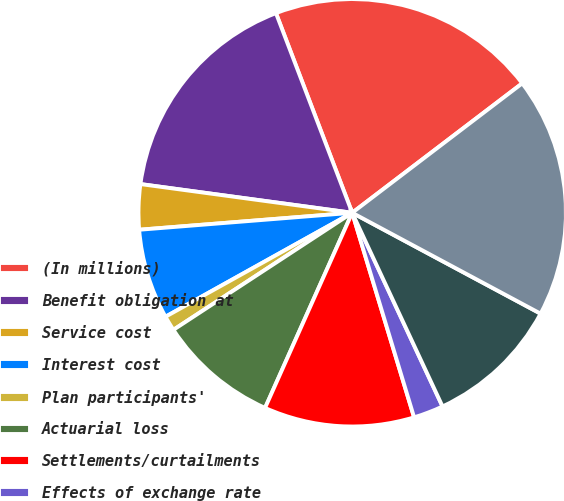Convert chart. <chart><loc_0><loc_0><loc_500><loc_500><pie_chart><fcel>(In millions)<fcel>Benefit obligation at<fcel>Service cost<fcel>Interest cost<fcel>Plan participants'<fcel>Actuarial loss<fcel>Settlements/curtailments<fcel>Effects of exchange rate<fcel>Benefits paid<fcel>Benefit obligation at end of<nl><fcel>20.45%<fcel>17.05%<fcel>3.41%<fcel>6.82%<fcel>1.14%<fcel>9.09%<fcel>11.36%<fcel>2.27%<fcel>10.23%<fcel>18.18%<nl></chart> 